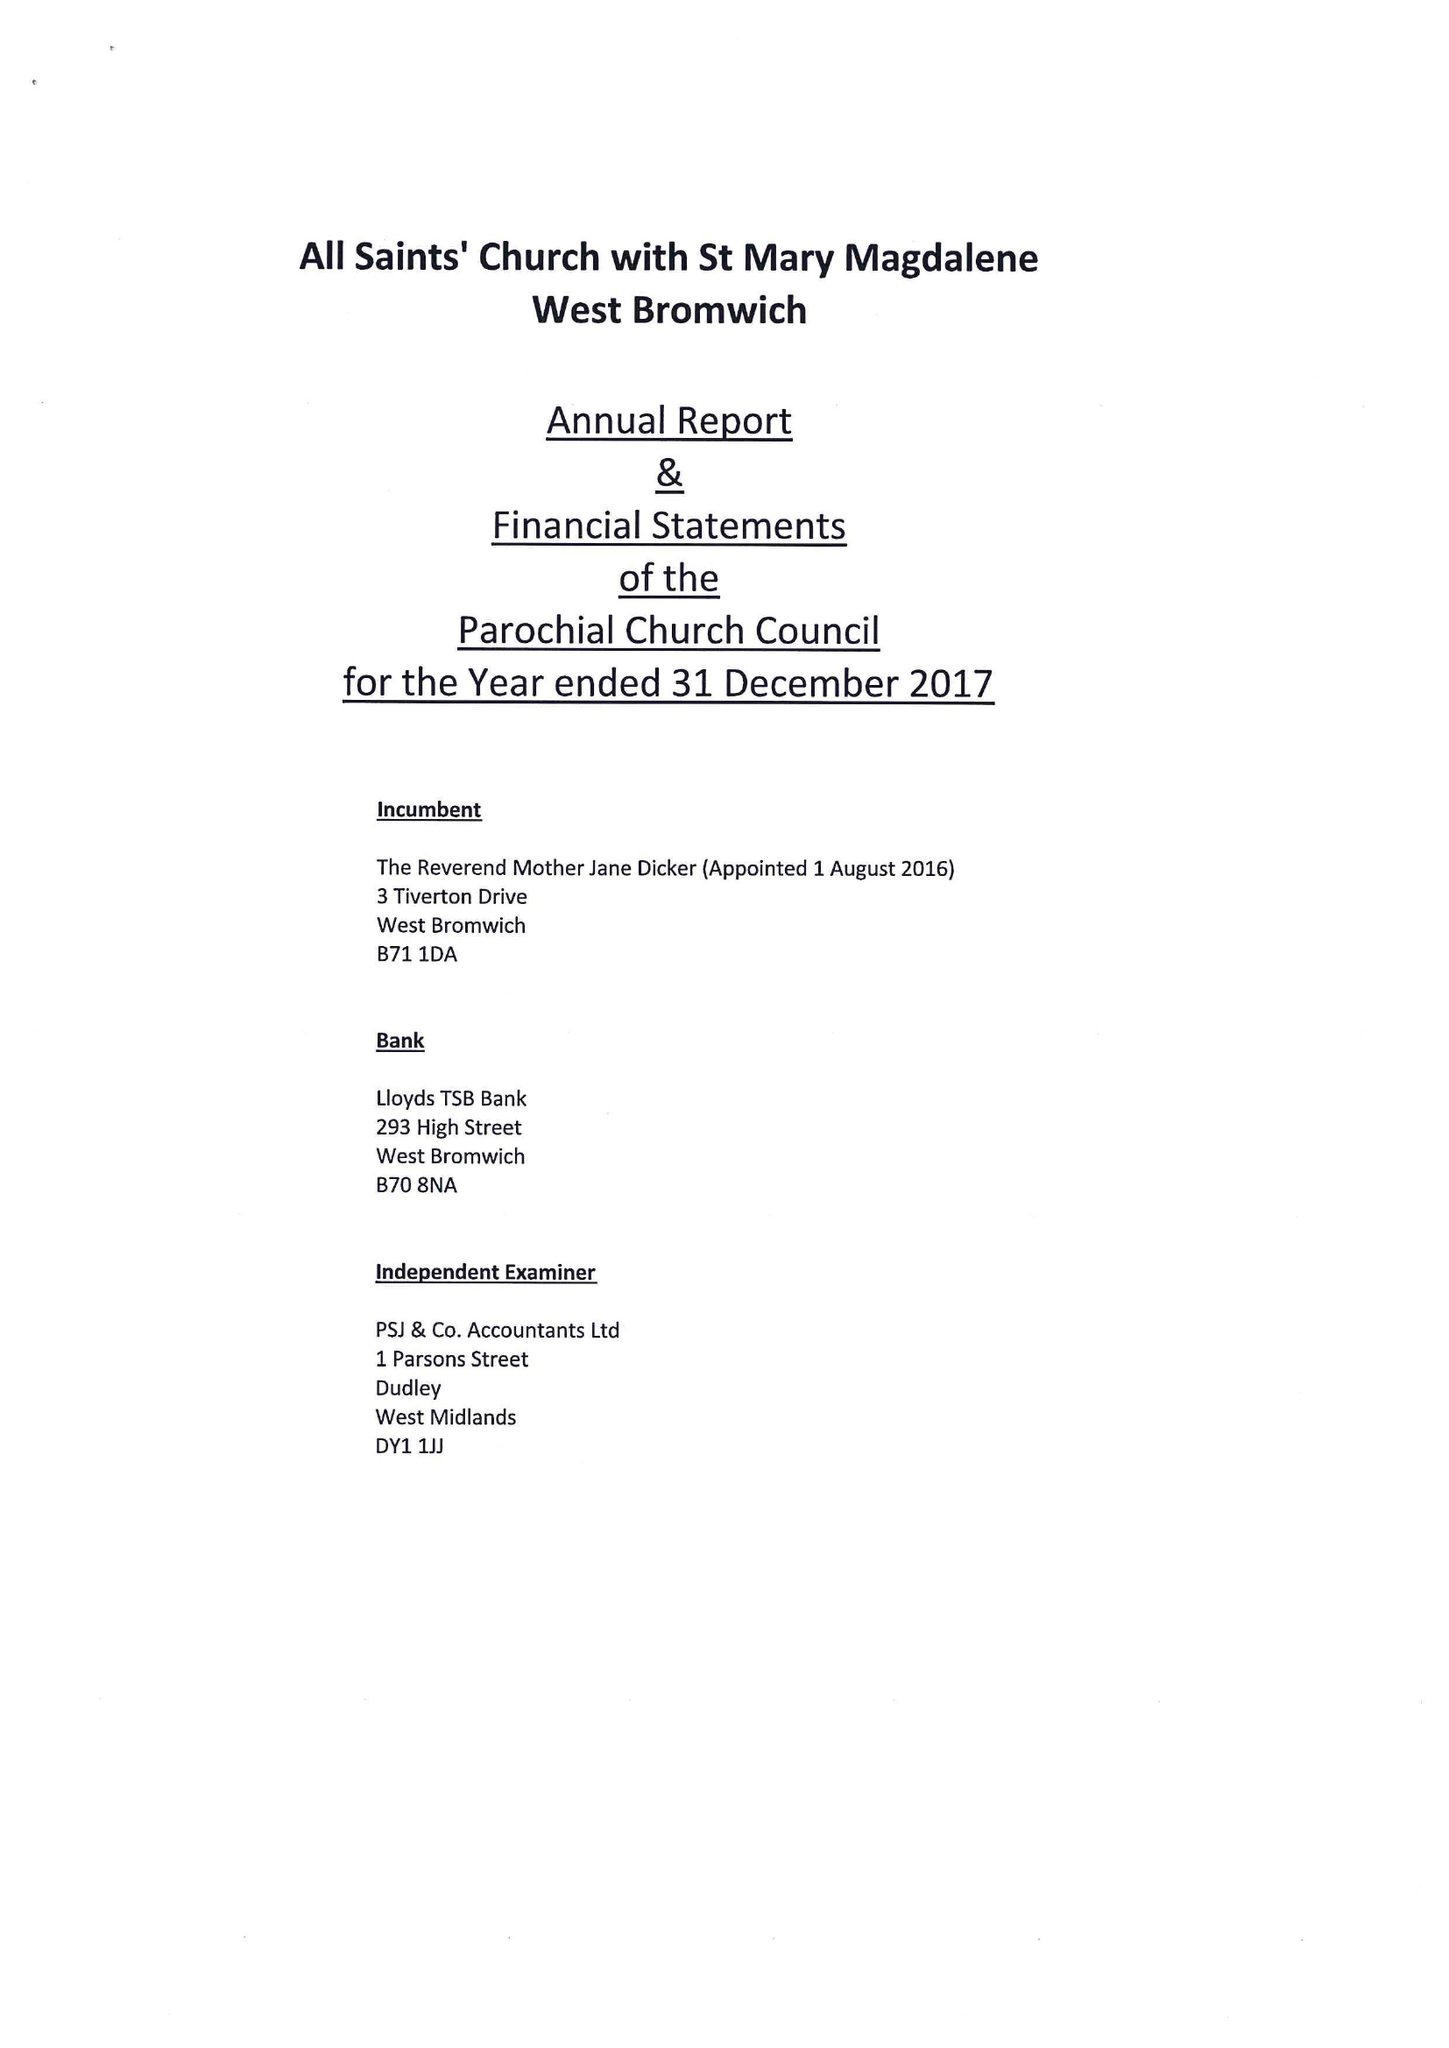What is the value for the address__postcode?
Answer the question using a single word or phrase. B43 6HU 